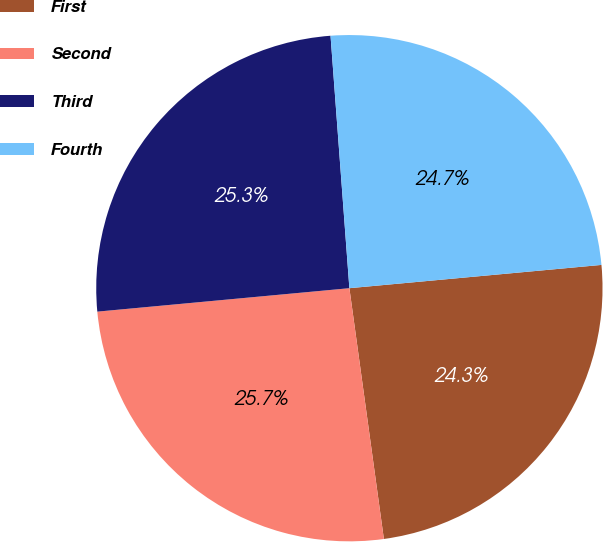Convert chart to OTSL. <chart><loc_0><loc_0><loc_500><loc_500><pie_chart><fcel>First<fcel>Second<fcel>Third<fcel>Fourth<nl><fcel>24.29%<fcel>25.7%<fcel>25.29%<fcel>24.72%<nl></chart> 